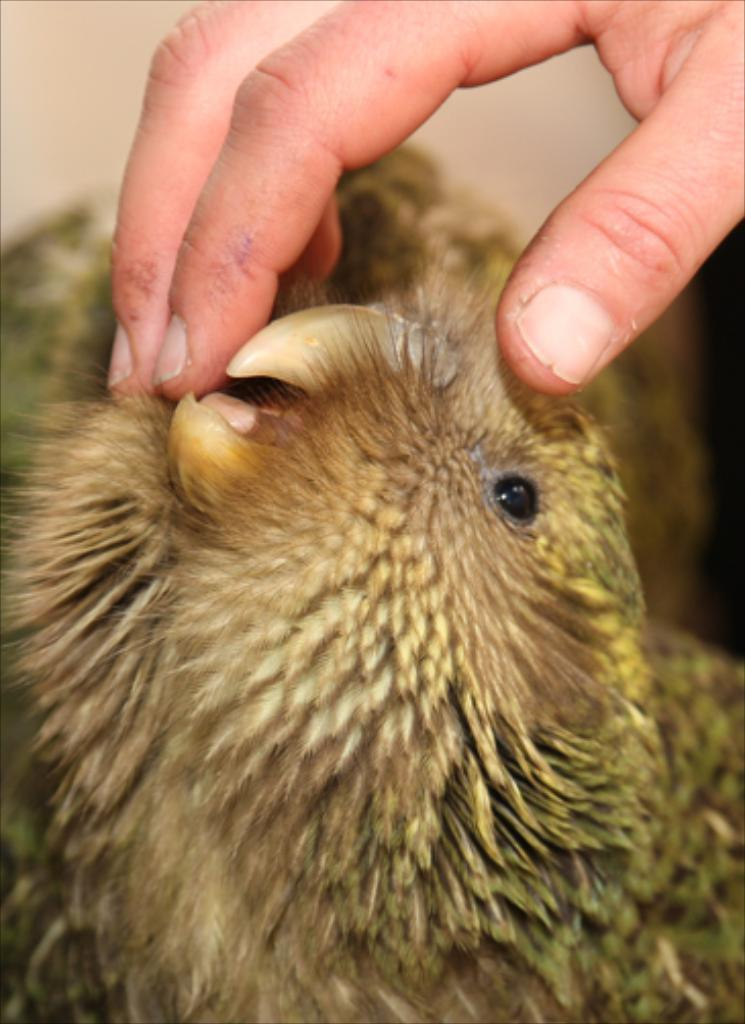What type of animal is present in the image? There is a bird in the image. What part of a person's body can be seen in the image? There are fingers visible in the image. Can you describe the background of the image? The background of the image is blurred. What type of poison is the bird using to attack the person in the image? There is no indication in the image that the bird is attacking the person or using any poison. 